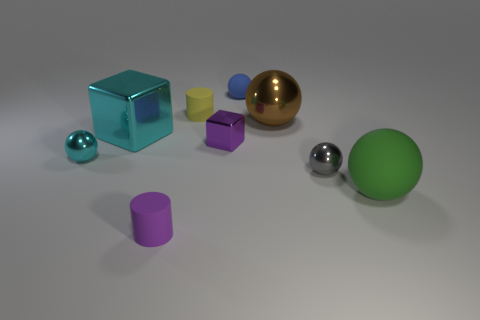Subtract all blue spheres. How many spheres are left? 4 Subtract all cyan balls. How many balls are left? 4 Subtract all blue cylinders. Subtract all yellow blocks. How many cylinders are left? 2 Add 1 purple metallic spheres. How many objects exist? 10 Subtract all blocks. How many objects are left? 7 Add 8 tiny purple metal cubes. How many tiny purple metal cubes exist? 9 Subtract 0 red cylinders. How many objects are left? 9 Subtract all large brown metallic things. Subtract all purple metal balls. How many objects are left? 8 Add 9 yellow objects. How many yellow objects are left? 10 